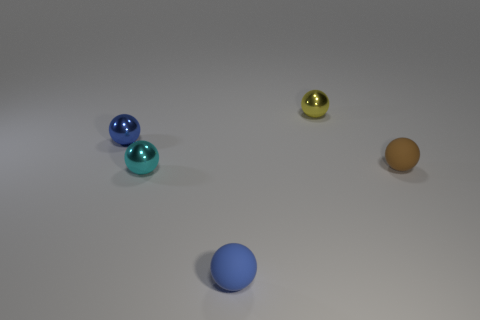How many other things are there of the same shape as the tiny yellow thing?
Ensure brevity in your answer.  4. How many large objects are yellow rubber balls or blue balls?
Keep it short and to the point. 0. How many metallic cylinders are there?
Provide a short and direct response. 0. There is a blue ball that is in front of the small blue metal thing; what is its material?
Provide a succinct answer. Rubber. There is a tiny yellow thing; are there any tiny brown matte things behind it?
Make the answer very short. No. Does the blue matte ball have the same size as the blue shiny object?
Provide a succinct answer. Yes. What number of cyan spheres are the same material as the brown object?
Provide a succinct answer. 0. What is the size of the ball that is on the right side of the yellow metallic object on the left side of the small brown rubber ball?
Your response must be concise. Small. There is a tiny thing that is behind the cyan metal sphere and in front of the tiny blue metal thing; what color is it?
Give a very brief answer. Brown. Is the brown matte thing the same shape as the blue rubber object?
Your response must be concise. Yes. 